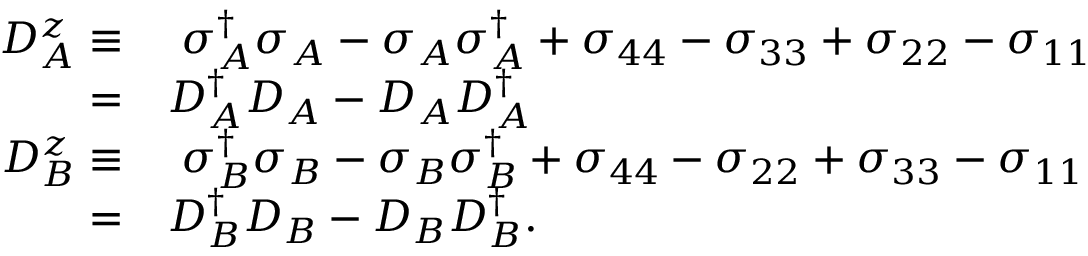<formula> <loc_0><loc_0><loc_500><loc_500>\begin{array} { r l } { D _ { A } ^ { z } \equiv } & { \sigma _ { A } ^ { \dagger } \sigma _ { A } - \sigma _ { A } \sigma _ { A } ^ { \dagger } + \sigma _ { 4 4 } - \sigma _ { 3 3 } + \sigma _ { 2 2 } - \sigma _ { 1 1 } } \\ { = } & { D _ { A } ^ { \dagger } D _ { A } - D _ { A } D _ { A } ^ { \dagger } } \\ { D _ { B } ^ { z } \equiv } & { \sigma _ { B } ^ { \dagger } \sigma _ { B } - \sigma _ { B } \sigma _ { B } ^ { \dagger } + \sigma _ { 4 4 } - \sigma _ { 2 2 } + \sigma _ { 3 3 } - \sigma _ { 1 1 } } \\ { = } & { D _ { B } ^ { \dagger } D _ { B } - D _ { B } D _ { B } ^ { \dagger } . } \end{array}</formula> 